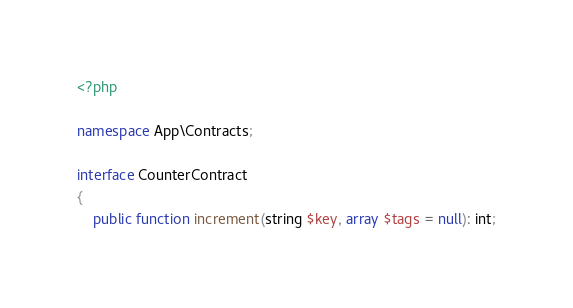<code> <loc_0><loc_0><loc_500><loc_500><_PHP_><?php

namespace App\Contracts;

interface CounterContract
{
    public function increment(string $key, array $tags = null): int;</code> 